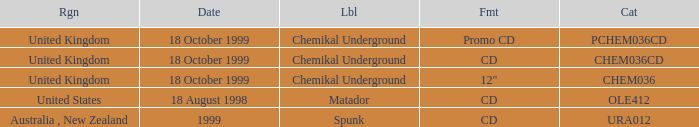What label has a catalog of chem036cd? Chemikal Underground. 